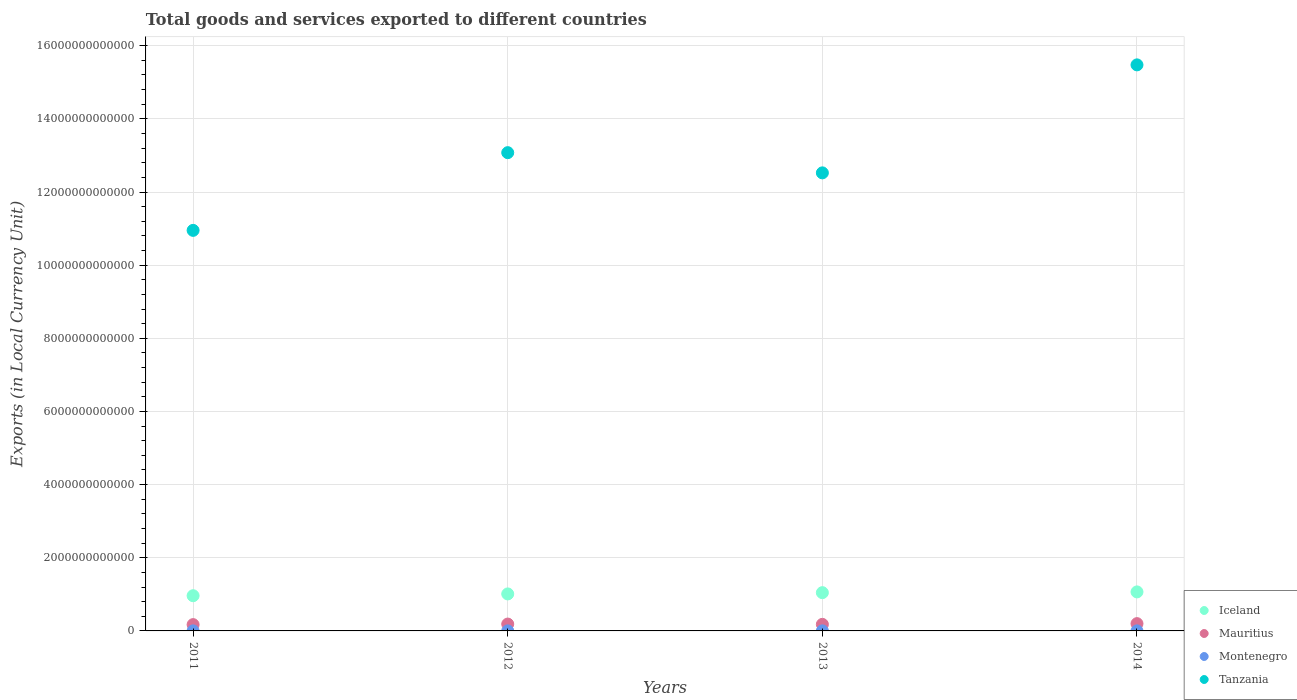How many different coloured dotlines are there?
Your answer should be compact. 4. Is the number of dotlines equal to the number of legend labels?
Offer a terse response. Yes. What is the Amount of goods and services exports in Montenegro in 2013?
Your answer should be very brief. 1.39e+09. Across all years, what is the maximum Amount of goods and services exports in Mauritius?
Your answer should be compact. 1.99e+11. Across all years, what is the minimum Amount of goods and services exports in Tanzania?
Offer a terse response. 1.10e+13. What is the total Amount of goods and services exports in Montenegro in the graph?
Offer a terse response. 5.55e+09. What is the difference between the Amount of goods and services exports in Montenegro in 2011 and that in 2014?
Make the answer very short. -5.54e+06. What is the difference between the Amount of goods and services exports in Iceland in 2011 and the Amount of goods and services exports in Tanzania in 2013?
Your response must be concise. -1.16e+13. What is the average Amount of goods and services exports in Tanzania per year?
Make the answer very short. 1.30e+13. In the year 2014, what is the difference between the Amount of goods and services exports in Iceland and Amount of goods and services exports in Tanzania?
Offer a very short reply. -1.44e+13. What is the ratio of the Amount of goods and services exports in Montenegro in 2013 to that in 2014?
Your answer should be very brief. 1. Is the Amount of goods and services exports in Mauritius in 2012 less than that in 2014?
Your answer should be very brief. Yes. What is the difference between the highest and the second highest Amount of goods and services exports in Montenegro?
Your response must be concise. 6.99e+05. What is the difference between the highest and the lowest Amount of goods and services exports in Mauritius?
Offer a very short reply. 2.68e+1. Is the sum of the Amount of goods and services exports in Tanzania in 2012 and 2013 greater than the maximum Amount of goods and services exports in Iceland across all years?
Your answer should be very brief. Yes. Is the Amount of goods and services exports in Montenegro strictly less than the Amount of goods and services exports in Mauritius over the years?
Your answer should be very brief. Yes. How many dotlines are there?
Your answer should be compact. 4. What is the difference between two consecutive major ticks on the Y-axis?
Your answer should be compact. 2.00e+12. Are the values on the major ticks of Y-axis written in scientific E-notation?
Offer a very short reply. No. Does the graph contain any zero values?
Offer a terse response. No. Does the graph contain grids?
Your answer should be very brief. Yes. What is the title of the graph?
Provide a short and direct response. Total goods and services exported to different countries. Does "Vanuatu" appear as one of the legend labels in the graph?
Make the answer very short. No. What is the label or title of the X-axis?
Your answer should be compact. Years. What is the label or title of the Y-axis?
Your response must be concise. Exports (in Local Currency Unit). What is the Exports (in Local Currency Unit) of Iceland in 2011?
Offer a terse response. 9.63e+11. What is the Exports (in Local Currency Unit) in Mauritius in 2011?
Make the answer very short. 1.73e+11. What is the Exports (in Local Currency Unit) in Montenegro in 2011?
Offer a very short reply. 1.38e+09. What is the Exports (in Local Currency Unit) of Tanzania in 2011?
Offer a very short reply. 1.10e+13. What is the Exports (in Local Currency Unit) of Iceland in 2012?
Make the answer very short. 1.01e+12. What is the Exports (in Local Currency Unit) of Mauritius in 2012?
Offer a very short reply. 1.88e+11. What is the Exports (in Local Currency Unit) of Montenegro in 2012?
Ensure brevity in your answer.  1.39e+09. What is the Exports (in Local Currency Unit) in Tanzania in 2012?
Give a very brief answer. 1.31e+13. What is the Exports (in Local Currency Unit) of Iceland in 2013?
Offer a terse response. 1.05e+12. What is the Exports (in Local Currency Unit) in Mauritius in 2013?
Your response must be concise. 1.79e+11. What is the Exports (in Local Currency Unit) in Montenegro in 2013?
Ensure brevity in your answer.  1.39e+09. What is the Exports (in Local Currency Unit) of Tanzania in 2013?
Your answer should be very brief. 1.25e+13. What is the Exports (in Local Currency Unit) of Iceland in 2014?
Offer a terse response. 1.07e+12. What is the Exports (in Local Currency Unit) of Mauritius in 2014?
Give a very brief answer. 1.99e+11. What is the Exports (in Local Currency Unit) of Montenegro in 2014?
Provide a succinct answer. 1.39e+09. What is the Exports (in Local Currency Unit) of Tanzania in 2014?
Provide a succinct answer. 1.55e+13. Across all years, what is the maximum Exports (in Local Currency Unit) in Iceland?
Your answer should be very brief. 1.07e+12. Across all years, what is the maximum Exports (in Local Currency Unit) in Mauritius?
Your answer should be very brief. 1.99e+11. Across all years, what is the maximum Exports (in Local Currency Unit) in Montenegro?
Keep it short and to the point. 1.39e+09. Across all years, what is the maximum Exports (in Local Currency Unit) in Tanzania?
Your answer should be very brief. 1.55e+13. Across all years, what is the minimum Exports (in Local Currency Unit) in Iceland?
Ensure brevity in your answer.  9.63e+11. Across all years, what is the minimum Exports (in Local Currency Unit) of Mauritius?
Give a very brief answer. 1.73e+11. Across all years, what is the minimum Exports (in Local Currency Unit) in Montenegro?
Offer a terse response. 1.38e+09. Across all years, what is the minimum Exports (in Local Currency Unit) of Tanzania?
Your response must be concise. 1.10e+13. What is the total Exports (in Local Currency Unit) in Iceland in the graph?
Your answer should be very brief. 4.09e+12. What is the total Exports (in Local Currency Unit) of Mauritius in the graph?
Your answer should be very brief. 7.39e+11. What is the total Exports (in Local Currency Unit) of Montenegro in the graph?
Offer a very short reply. 5.55e+09. What is the total Exports (in Local Currency Unit) of Tanzania in the graph?
Your response must be concise. 5.20e+13. What is the difference between the Exports (in Local Currency Unit) of Iceland in 2011 and that in 2012?
Offer a very short reply. -4.89e+1. What is the difference between the Exports (in Local Currency Unit) in Mauritius in 2011 and that in 2012?
Your response must be concise. -1.51e+1. What is the difference between the Exports (in Local Currency Unit) of Montenegro in 2011 and that in 2012?
Keep it short and to the point. -6.83e+06. What is the difference between the Exports (in Local Currency Unit) of Tanzania in 2011 and that in 2012?
Ensure brevity in your answer.  -2.12e+12. What is the difference between the Exports (in Local Currency Unit) of Iceland in 2011 and that in 2013?
Provide a succinct answer. -8.36e+1. What is the difference between the Exports (in Local Currency Unit) in Mauritius in 2011 and that in 2013?
Make the answer very short. -6.77e+09. What is the difference between the Exports (in Local Currency Unit) in Montenegro in 2011 and that in 2013?
Provide a succinct answer. -7.53e+06. What is the difference between the Exports (in Local Currency Unit) in Tanzania in 2011 and that in 2013?
Offer a very short reply. -1.57e+12. What is the difference between the Exports (in Local Currency Unit) in Iceland in 2011 and that in 2014?
Offer a terse response. -1.04e+11. What is the difference between the Exports (in Local Currency Unit) of Mauritius in 2011 and that in 2014?
Keep it short and to the point. -2.68e+1. What is the difference between the Exports (in Local Currency Unit) in Montenegro in 2011 and that in 2014?
Your answer should be compact. -5.54e+06. What is the difference between the Exports (in Local Currency Unit) of Tanzania in 2011 and that in 2014?
Provide a succinct answer. -4.53e+12. What is the difference between the Exports (in Local Currency Unit) in Iceland in 2012 and that in 2013?
Provide a short and direct response. -3.47e+1. What is the difference between the Exports (in Local Currency Unit) of Mauritius in 2012 and that in 2013?
Your response must be concise. 8.36e+09. What is the difference between the Exports (in Local Currency Unit) in Montenegro in 2012 and that in 2013?
Ensure brevity in your answer.  -6.99e+05. What is the difference between the Exports (in Local Currency Unit) in Tanzania in 2012 and that in 2013?
Provide a short and direct response. 5.52e+11. What is the difference between the Exports (in Local Currency Unit) of Iceland in 2012 and that in 2014?
Ensure brevity in your answer.  -5.53e+1. What is the difference between the Exports (in Local Currency Unit) of Mauritius in 2012 and that in 2014?
Offer a terse response. -1.17e+1. What is the difference between the Exports (in Local Currency Unit) of Montenegro in 2012 and that in 2014?
Ensure brevity in your answer.  1.29e+06. What is the difference between the Exports (in Local Currency Unit) of Tanzania in 2012 and that in 2014?
Offer a very short reply. -2.40e+12. What is the difference between the Exports (in Local Currency Unit) of Iceland in 2013 and that in 2014?
Offer a terse response. -2.06e+1. What is the difference between the Exports (in Local Currency Unit) of Mauritius in 2013 and that in 2014?
Give a very brief answer. -2.00e+1. What is the difference between the Exports (in Local Currency Unit) of Montenegro in 2013 and that in 2014?
Keep it short and to the point. 1.99e+06. What is the difference between the Exports (in Local Currency Unit) in Tanzania in 2013 and that in 2014?
Your answer should be compact. -2.95e+12. What is the difference between the Exports (in Local Currency Unit) of Iceland in 2011 and the Exports (in Local Currency Unit) of Mauritius in 2012?
Your answer should be very brief. 7.75e+11. What is the difference between the Exports (in Local Currency Unit) in Iceland in 2011 and the Exports (in Local Currency Unit) in Montenegro in 2012?
Your answer should be very brief. 9.61e+11. What is the difference between the Exports (in Local Currency Unit) in Iceland in 2011 and the Exports (in Local Currency Unit) in Tanzania in 2012?
Your answer should be compact. -1.21e+13. What is the difference between the Exports (in Local Currency Unit) of Mauritius in 2011 and the Exports (in Local Currency Unit) of Montenegro in 2012?
Provide a short and direct response. 1.71e+11. What is the difference between the Exports (in Local Currency Unit) in Mauritius in 2011 and the Exports (in Local Currency Unit) in Tanzania in 2012?
Offer a terse response. -1.29e+13. What is the difference between the Exports (in Local Currency Unit) in Montenegro in 2011 and the Exports (in Local Currency Unit) in Tanzania in 2012?
Provide a short and direct response. -1.31e+13. What is the difference between the Exports (in Local Currency Unit) in Iceland in 2011 and the Exports (in Local Currency Unit) in Mauritius in 2013?
Offer a terse response. 7.83e+11. What is the difference between the Exports (in Local Currency Unit) in Iceland in 2011 and the Exports (in Local Currency Unit) in Montenegro in 2013?
Ensure brevity in your answer.  9.61e+11. What is the difference between the Exports (in Local Currency Unit) of Iceland in 2011 and the Exports (in Local Currency Unit) of Tanzania in 2013?
Make the answer very short. -1.16e+13. What is the difference between the Exports (in Local Currency Unit) of Mauritius in 2011 and the Exports (in Local Currency Unit) of Montenegro in 2013?
Keep it short and to the point. 1.71e+11. What is the difference between the Exports (in Local Currency Unit) in Mauritius in 2011 and the Exports (in Local Currency Unit) in Tanzania in 2013?
Give a very brief answer. -1.24e+13. What is the difference between the Exports (in Local Currency Unit) of Montenegro in 2011 and the Exports (in Local Currency Unit) of Tanzania in 2013?
Provide a succinct answer. -1.25e+13. What is the difference between the Exports (in Local Currency Unit) in Iceland in 2011 and the Exports (in Local Currency Unit) in Mauritius in 2014?
Ensure brevity in your answer.  7.63e+11. What is the difference between the Exports (in Local Currency Unit) of Iceland in 2011 and the Exports (in Local Currency Unit) of Montenegro in 2014?
Provide a short and direct response. 9.61e+11. What is the difference between the Exports (in Local Currency Unit) of Iceland in 2011 and the Exports (in Local Currency Unit) of Tanzania in 2014?
Offer a terse response. -1.45e+13. What is the difference between the Exports (in Local Currency Unit) of Mauritius in 2011 and the Exports (in Local Currency Unit) of Montenegro in 2014?
Your answer should be very brief. 1.71e+11. What is the difference between the Exports (in Local Currency Unit) of Mauritius in 2011 and the Exports (in Local Currency Unit) of Tanzania in 2014?
Offer a terse response. -1.53e+13. What is the difference between the Exports (in Local Currency Unit) in Montenegro in 2011 and the Exports (in Local Currency Unit) in Tanzania in 2014?
Ensure brevity in your answer.  -1.55e+13. What is the difference between the Exports (in Local Currency Unit) in Iceland in 2012 and the Exports (in Local Currency Unit) in Mauritius in 2013?
Offer a very short reply. 8.32e+11. What is the difference between the Exports (in Local Currency Unit) of Iceland in 2012 and the Exports (in Local Currency Unit) of Montenegro in 2013?
Offer a very short reply. 1.01e+12. What is the difference between the Exports (in Local Currency Unit) in Iceland in 2012 and the Exports (in Local Currency Unit) in Tanzania in 2013?
Make the answer very short. -1.15e+13. What is the difference between the Exports (in Local Currency Unit) of Mauritius in 2012 and the Exports (in Local Currency Unit) of Montenegro in 2013?
Make the answer very short. 1.86e+11. What is the difference between the Exports (in Local Currency Unit) of Mauritius in 2012 and the Exports (in Local Currency Unit) of Tanzania in 2013?
Your answer should be very brief. -1.23e+13. What is the difference between the Exports (in Local Currency Unit) in Montenegro in 2012 and the Exports (in Local Currency Unit) in Tanzania in 2013?
Provide a succinct answer. -1.25e+13. What is the difference between the Exports (in Local Currency Unit) in Iceland in 2012 and the Exports (in Local Currency Unit) in Mauritius in 2014?
Your answer should be compact. 8.12e+11. What is the difference between the Exports (in Local Currency Unit) in Iceland in 2012 and the Exports (in Local Currency Unit) in Montenegro in 2014?
Make the answer very short. 1.01e+12. What is the difference between the Exports (in Local Currency Unit) in Iceland in 2012 and the Exports (in Local Currency Unit) in Tanzania in 2014?
Your answer should be very brief. -1.45e+13. What is the difference between the Exports (in Local Currency Unit) of Mauritius in 2012 and the Exports (in Local Currency Unit) of Montenegro in 2014?
Your answer should be very brief. 1.86e+11. What is the difference between the Exports (in Local Currency Unit) of Mauritius in 2012 and the Exports (in Local Currency Unit) of Tanzania in 2014?
Give a very brief answer. -1.53e+13. What is the difference between the Exports (in Local Currency Unit) in Montenegro in 2012 and the Exports (in Local Currency Unit) in Tanzania in 2014?
Give a very brief answer. -1.55e+13. What is the difference between the Exports (in Local Currency Unit) of Iceland in 2013 and the Exports (in Local Currency Unit) of Mauritius in 2014?
Your answer should be very brief. 8.47e+11. What is the difference between the Exports (in Local Currency Unit) of Iceland in 2013 and the Exports (in Local Currency Unit) of Montenegro in 2014?
Offer a terse response. 1.04e+12. What is the difference between the Exports (in Local Currency Unit) in Iceland in 2013 and the Exports (in Local Currency Unit) in Tanzania in 2014?
Your response must be concise. -1.44e+13. What is the difference between the Exports (in Local Currency Unit) of Mauritius in 2013 and the Exports (in Local Currency Unit) of Montenegro in 2014?
Ensure brevity in your answer.  1.78e+11. What is the difference between the Exports (in Local Currency Unit) in Mauritius in 2013 and the Exports (in Local Currency Unit) in Tanzania in 2014?
Give a very brief answer. -1.53e+13. What is the difference between the Exports (in Local Currency Unit) of Montenegro in 2013 and the Exports (in Local Currency Unit) of Tanzania in 2014?
Offer a terse response. -1.55e+13. What is the average Exports (in Local Currency Unit) in Iceland per year?
Keep it short and to the point. 1.02e+12. What is the average Exports (in Local Currency Unit) of Mauritius per year?
Provide a short and direct response. 1.85e+11. What is the average Exports (in Local Currency Unit) of Montenegro per year?
Your answer should be very brief. 1.39e+09. What is the average Exports (in Local Currency Unit) of Tanzania per year?
Make the answer very short. 1.30e+13. In the year 2011, what is the difference between the Exports (in Local Currency Unit) in Iceland and Exports (in Local Currency Unit) in Mauritius?
Offer a very short reply. 7.90e+11. In the year 2011, what is the difference between the Exports (in Local Currency Unit) in Iceland and Exports (in Local Currency Unit) in Montenegro?
Give a very brief answer. 9.61e+11. In the year 2011, what is the difference between the Exports (in Local Currency Unit) of Iceland and Exports (in Local Currency Unit) of Tanzania?
Keep it short and to the point. -9.99e+12. In the year 2011, what is the difference between the Exports (in Local Currency Unit) in Mauritius and Exports (in Local Currency Unit) in Montenegro?
Ensure brevity in your answer.  1.71e+11. In the year 2011, what is the difference between the Exports (in Local Currency Unit) in Mauritius and Exports (in Local Currency Unit) in Tanzania?
Keep it short and to the point. -1.08e+13. In the year 2011, what is the difference between the Exports (in Local Currency Unit) of Montenegro and Exports (in Local Currency Unit) of Tanzania?
Your response must be concise. -1.10e+13. In the year 2012, what is the difference between the Exports (in Local Currency Unit) of Iceland and Exports (in Local Currency Unit) of Mauritius?
Offer a terse response. 8.24e+11. In the year 2012, what is the difference between the Exports (in Local Currency Unit) in Iceland and Exports (in Local Currency Unit) in Montenegro?
Offer a very short reply. 1.01e+12. In the year 2012, what is the difference between the Exports (in Local Currency Unit) in Iceland and Exports (in Local Currency Unit) in Tanzania?
Make the answer very short. -1.21e+13. In the year 2012, what is the difference between the Exports (in Local Currency Unit) of Mauritius and Exports (in Local Currency Unit) of Montenegro?
Offer a very short reply. 1.86e+11. In the year 2012, what is the difference between the Exports (in Local Currency Unit) in Mauritius and Exports (in Local Currency Unit) in Tanzania?
Provide a short and direct response. -1.29e+13. In the year 2012, what is the difference between the Exports (in Local Currency Unit) in Montenegro and Exports (in Local Currency Unit) in Tanzania?
Keep it short and to the point. -1.31e+13. In the year 2013, what is the difference between the Exports (in Local Currency Unit) of Iceland and Exports (in Local Currency Unit) of Mauritius?
Keep it short and to the point. 8.67e+11. In the year 2013, what is the difference between the Exports (in Local Currency Unit) of Iceland and Exports (in Local Currency Unit) of Montenegro?
Your response must be concise. 1.04e+12. In the year 2013, what is the difference between the Exports (in Local Currency Unit) in Iceland and Exports (in Local Currency Unit) in Tanzania?
Make the answer very short. -1.15e+13. In the year 2013, what is the difference between the Exports (in Local Currency Unit) in Mauritius and Exports (in Local Currency Unit) in Montenegro?
Provide a succinct answer. 1.78e+11. In the year 2013, what is the difference between the Exports (in Local Currency Unit) in Mauritius and Exports (in Local Currency Unit) in Tanzania?
Provide a succinct answer. -1.23e+13. In the year 2013, what is the difference between the Exports (in Local Currency Unit) in Montenegro and Exports (in Local Currency Unit) in Tanzania?
Provide a short and direct response. -1.25e+13. In the year 2014, what is the difference between the Exports (in Local Currency Unit) in Iceland and Exports (in Local Currency Unit) in Mauritius?
Your response must be concise. 8.67e+11. In the year 2014, what is the difference between the Exports (in Local Currency Unit) of Iceland and Exports (in Local Currency Unit) of Montenegro?
Offer a very short reply. 1.07e+12. In the year 2014, what is the difference between the Exports (in Local Currency Unit) of Iceland and Exports (in Local Currency Unit) of Tanzania?
Your answer should be compact. -1.44e+13. In the year 2014, what is the difference between the Exports (in Local Currency Unit) of Mauritius and Exports (in Local Currency Unit) of Montenegro?
Give a very brief answer. 1.98e+11. In the year 2014, what is the difference between the Exports (in Local Currency Unit) in Mauritius and Exports (in Local Currency Unit) in Tanzania?
Give a very brief answer. -1.53e+13. In the year 2014, what is the difference between the Exports (in Local Currency Unit) in Montenegro and Exports (in Local Currency Unit) in Tanzania?
Offer a very short reply. -1.55e+13. What is the ratio of the Exports (in Local Currency Unit) in Iceland in 2011 to that in 2012?
Offer a very short reply. 0.95. What is the ratio of the Exports (in Local Currency Unit) in Mauritius in 2011 to that in 2012?
Provide a succinct answer. 0.92. What is the ratio of the Exports (in Local Currency Unit) of Tanzania in 2011 to that in 2012?
Keep it short and to the point. 0.84. What is the ratio of the Exports (in Local Currency Unit) in Mauritius in 2011 to that in 2013?
Give a very brief answer. 0.96. What is the ratio of the Exports (in Local Currency Unit) in Montenegro in 2011 to that in 2013?
Keep it short and to the point. 0.99. What is the ratio of the Exports (in Local Currency Unit) in Tanzania in 2011 to that in 2013?
Your answer should be very brief. 0.87. What is the ratio of the Exports (in Local Currency Unit) in Iceland in 2011 to that in 2014?
Make the answer very short. 0.9. What is the ratio of the Exports (in Local Currency Unit) in Mauritius in 2011 to that in 2014?
Provide a short and direct response. 0.87. What is the ratio of the Exports (in Local Currency Unit) of Tanzania in 2011 to that in 2014?
Provide a short and direct response. 0.71. What is the ratio of the Exports (in Local Currency Unit) of Iceland in 2012 to that in 2013?
Your answer should be very brief. 0.97. What is the ratio of the Exports (in Local Currency Unit) in Mauritius in 2012 to that in 2013?
Ensure brevity in your answer.  1.05. What is the ratio of the Exports (in Local Currency Unit) in Tanzania in 2012 to that in 2013?
Give a very brief answer. 1.04. What is the ratio of the Exports (in Local Currency Unit) of Iceland in 2012 to that in 2014?
Provide a short and direct response. 0.95. What is the ratio of the Exports (in Local Currency Unit) of Mauritius in 2012 to that in 2014?
Make the answer very short. 0.94. What is the ratio of the Exports (in Local Currency Unit) in Tanzania in 2012 to that in 2014?
Make the answer very short. 0.84. What is the ratio of the Exports (in Local Currency Unit) in Iceland in 2013 to that in 2014?
Keep it short and to the point. 0.98. What is the ratio of the Exports (in Local Currency Unit) of Mauritius in 2013 to that in 2014?
Your answer should be very brief. 0.9. What is the ratio of the Exports (in Local Currency Unit) of Tanzania in 2013 to that in 2014?
Provide a short and direct response. 0.81. What is the difference between the highest and the second highest Exports (in Local Currency Unit) in Iceland?
Provide a succinct answer. 2.06e+1. What is the difference between the highest and the second highest Exports (in Local Currency Unit) of Mauritius?
Provide a short and direct response. 1.17e+1. What is the difference between the highest and the second highest Exports (in Local Currency Unit) of Montenegro?
Give a very brief answer. 6.99e+05. What is the difference between the highest and the second highest Exports (in Local Currency Unit) of Tanzania?
Your answer should be compact. 2.40e+12. What is the difference between the highest and the lowest Exports (in Local Currency Unit) in Iceland?
Ensure brevity in your answer.  1.04e+11. What is the difference between the highest and the lowest Exports (in Local Currency Unit) of Mauritius?
Provide a short and direct response. 2.68e+1. What is the difference between the highest and the lowest Exports (in Local Currency Unit) of Montenegro?
Your answer should be compact. 7.53e+06. What is the difference between the highest and the lowest Exports (in Local Currency Unit) in Tanzania?
Make the answer very short. 4.53e+12. 